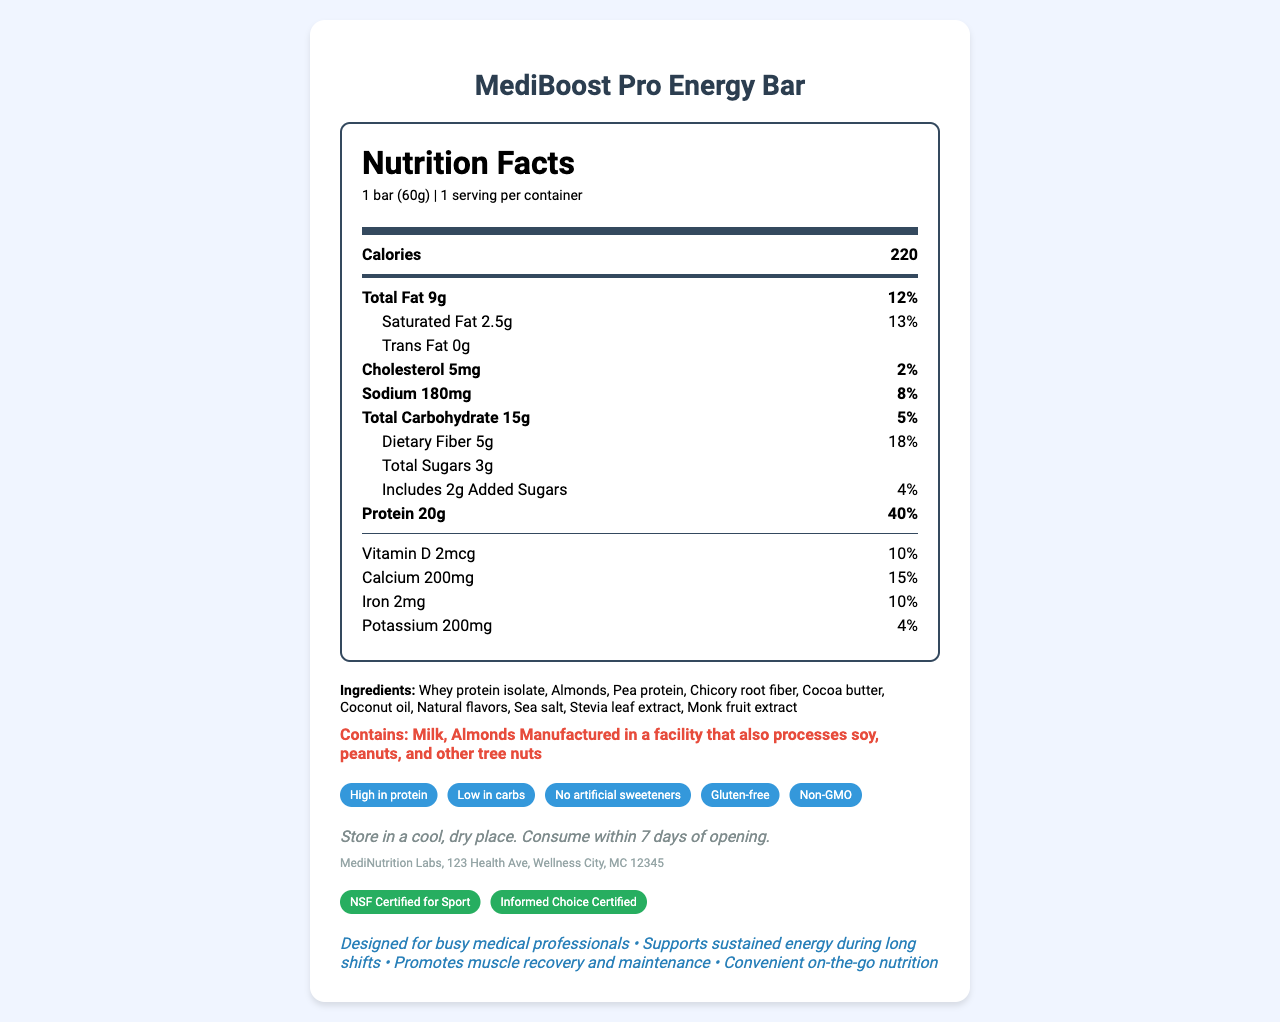what is the serving size? The nutrition label specifies that the serving size is "1 bar (60g)".
Answer: 1 bar (60g) how many calories are in one serving? The nutrition label lists the calories per serving as 220.
Answer: 220 what is the total amount of protein in one bar? According to the nutrition facts, each bar contains 20g of protein.
Answer: 20g how much dietary fiber does the bar provide? The nutrition label states that the dietary fiber content is 5g per bar.
Answer: 5g what are the main ingredients of the MediBoost Pro Energy Bar? The ingredients section lists these items as the main ingredients.
Answer: Whey protein isolate, Almonds, Pea protein, Chicory root fiber, Cocoa butter, Coconut oil, Natural flavors, Sea salt, Stevia leaf extract, Monk fruit extract which allergen does this product contain? A. Soy B. Milk C. Peanuts D. Wheat The allergen information lists milk and almonds.
Answer: B what is the percentage daily value of saturated fat in this bar? The nutrition label shows that the saturated fat content is 2.5g, which is 13% of the daily value.
Answer: 13% is this product gluten-free? The special features section states that the product is gluten-free.
Answer: Yes how many servings are there per container? The nutrition label specifies that there is 1 serving per container.
Answer: 1 which vitamin is present, and what is its daily value percentage? A. Vitamin A, 10% B. Vitamin B12, 15% C. Vitamin D, 10% D. Vitamin C, 15% The nutrition label lists Vitamin D with a daily value percentage of 10%.
Answer: C what is the manufacturer’s contact information? The manufacturer's information is provided at the bottom of the document.
Answer: MediNutrition Labs, 123 Health Ave, Wellness City, MC 12345 what are the storage instructions for this product? The storage instructions are specified in a dedicated section in the document.
Answer: Store in a cool, dry place. Consume within 7 days of opening. is this product suitable for someone who is allergic to peanuts? The allergen information indicates that it's manufactured in a facility that processes peanuts.
Answer: No what certifications does this product have? The certifications section lists NSF Certified for Sport and Informed Choice Certified.
Answer: NSF Certified for Sport, Informed Choice Certified what is the primary market audience for this product? The marketing claims section states that the product is designed for busy medical professionals.
Answer: Busy medical professionals what is the amount of sodium in one serving? The nutrition facts list 180mg of sodium per serving.
Answer: 180mg does this bar contain any trans fat? The nutrition label shows 0g of trans fat.
Answer: No summarize the main nutritional benefits of the MediBoost Pro Energy Bar. The summary should include the high protein content, low carbs, the presence of vitamins and minerals, and its design purpose for medical professionals.
Answer: The MediBoost Pro Energy Bar is high in protein (20g per serving), low in carbs (15g per serving), and contains important vitamins and minerals such as Vitamin D, calcium, iron, and potassium. It is designed to support sustained energy during long shifts for busy medical professionals. is this product organic? The document does not provide any mention or certification concerning the product being organic.
Answer: Not enough information 